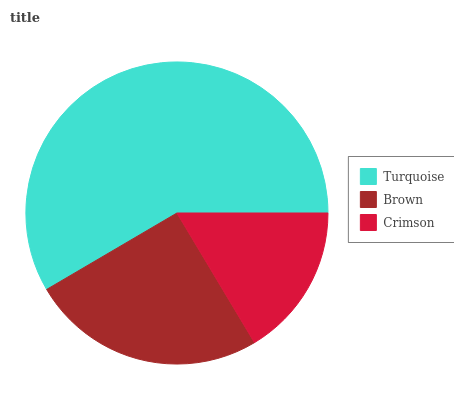Is Crimson the minimum?
Answer yes or no. Yes. Is Turquoise the maximum?
Answer yes or no. Yes. Is Brown the minimum?
Answer yes or no. No. Is Brown the maximum?
Answer yes or no. No. Is Turquoise greater than Brown?
Answer yes or no. Yes. Is Brown less than Turquoise?
Answer yes or no. Yes. Is Brown greater than Turquoise?
Answer yes or no. No. Is Turquoise less than Brown?
Answer yes or no. No. Is Brown the high median?
Answer yes or no. Yes. Is Brown the low median?
Answer yes or no. Yes. Is Crimson the high median?
Answer yes or no. No. Is Crimson the low median?
Answer yes or no. No. 